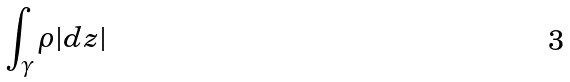Convert formula to latex. <formula><loc_0><loc_0><loc_500><loc_500>\int _ { \gamma } \rho | d z |</formula> 